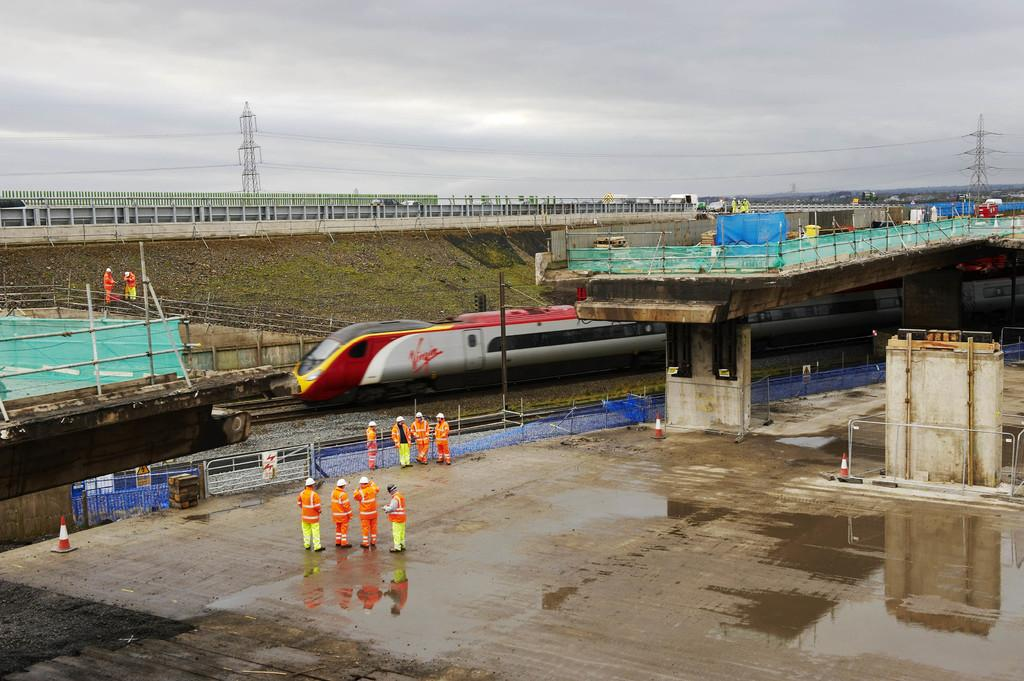<image>
Give a short and clear explanation of the subsequent image. four man looking at a bullet train owned by Virgin 